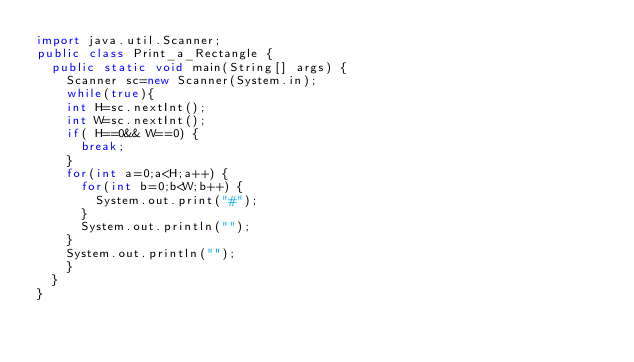<code> <loc_0><loc_0><loc_500><loc_500><_Java_>import java.util.Scanner;
public class Print_a_Rectangle {
	public static void main(String[] args) {
		Scanner sc=new Scanner(System.in);
		while(true){
		int H=sc.nextInt();
		int W=sc.nextInt();
		if( H==0&& W==0) {
			break;
		}
		for(int a=0;a<H;a++) {
			for(int b=0;b<W;b++) {
				System.out.print("#");
			}
			System.out.println("");
		}
		System.out.println("");
		}
	}
}


</code> 